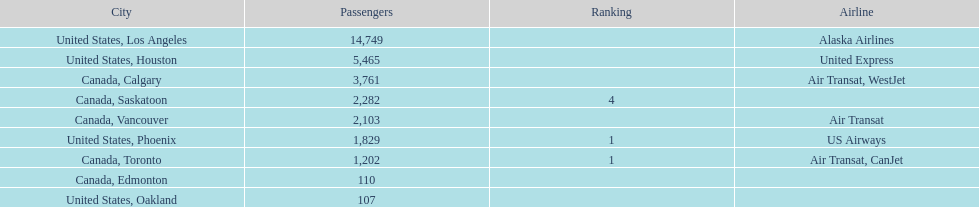I'm looking to parse the entire table for insights. Could you assist me with that? {'header': ['City', 'Passengers', 'Ranking', 'Airline'], 'rows': [['United States, Los Angeles', '14,749', '', 'Alaska Airlines'], ['United States, Houston', '5,465', '', 'United Express'], ['Canada, Calgary', '3,761', '', 'Air Transat, WestJet'], ['Canada, Saskatoon', '2,282', '4', ''], ['Canada, Vancouver', '2,103', '', 'Air Transat'], ['United States, Phoenix', '1,829', '1', 'US Airways'], ['Canada, Toronto', '1,202', '1', 'Air Transat, CanJet'], ['Canada, Edmonton', '110', '', ''], ['United States, Oakland', '107', '', '']]} How many airlines have a steady ranking? 4. 